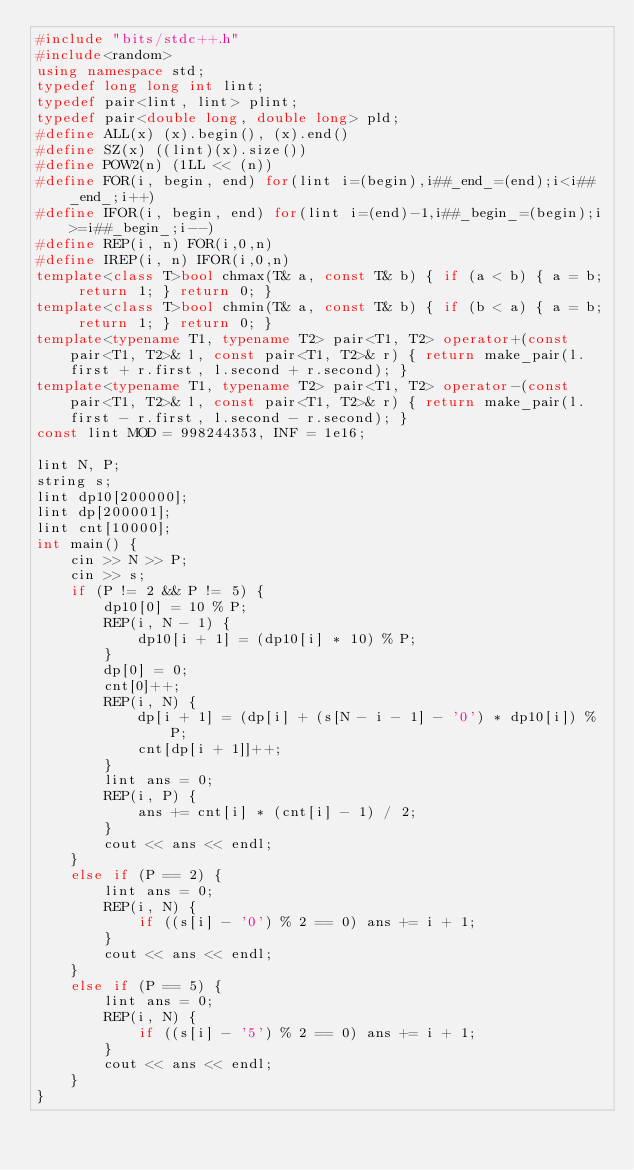Convert code to text. <code><loc_0><loc_0><loc_500><loc_500><_C++_>#include "bits/stdc++.h"
#include<random>
using namespace std;
typedef long long int lint;
typedef pair<lint, lint> plint;
typedef pair<double long, double long> pld;
#define ALL(x) (x).begin(), (x).end()
#define SZ(x) ((lint)(x).size())
#define POW2(n) (1LL << (n))
#define FOR(i, begin, end) for(lint i=(begin),i##_end_=(end);i<i##_end_;i++)
#define IFOR(i, begin, end) for(lint i=(end)-1,i##_begin_=(begin);i>=i##_begin_;i--)
#define REP(i, n) FOR(i,0,n)
#define IREP(i, n) IFOR(i,0,n)
template<class T>bool chmax(T& a, const T& b) { if (a < b) { a = b; return 1; } return 0; }
template<class T>bool chmin(T& a, const T& b) { if (b < a) { a = b; return 1; } return 0; }
template<typename T1, typename T2> pair<T1, T2> operator+(const pair<T1, T2>& l, const pair<T1, T2>& r) { return make_pair(l.first + r.first, l.second + r.second); }
template<typename T1, typename T2> pair<T1, T2> operator-(const pair<T1, T2>& l, const pair<T1, T2>& r) { return make_pair(l.first - r.first, l.second - r.second); }
const lint MOD = 998244353, INF = 1e16;

lint N, P;
string s;
lint dp10[200000];
lint dp[200001];
lint cnt[10000];
int main() {
	cin >> N >> P;
	cin >> s;
	if (P != 2 && P != 5) {
		dp10[0] = 10 % P;
		REP(i, N - 1) {
			dp10[i + 1] = (dp10[i] * 10) % P;
		}
		dp[0] = 0;
		cnt[0]++;
		REP(i, N) {
			dp[i + 1] = (dp[i] + (s[N - i - 1] - '0') * dp10[i]) % P;
			cnt[dp[i + 1]]++;
		}
		lint ans = 0;
		REP(i, P) {
			ans += cnt[i] * (cnt[i] - 1) / 2;
		}
		cout << ans << endl;
	}
	else if (P == 2) {
		lint ans = 0;
		REP(i, N) {
			if ((s[i] - '0') % 2 == 0) ans += i + 1;
		}
		cout << ans << endl;
	}
	else if (P == 5) {
		lint ans = 0;
		REP(i, N) {
			if ((s[i] - '5') % 2 == 0) ans += i + 1;
		}
		cout << ans << endl;
	}
}
</code> 